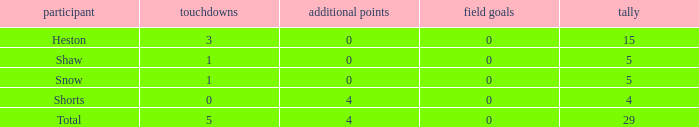Parse the table in full. {'header': ['participant', 'touchdowns', 'additional points', 'field goals', 'tally'], 'rows': [['Heston', '3', '0', '0', '15'], ['Shaw', '1', '0', '0', '5'], ['Snow', '1', '0', '0', '5'], ['Shorts', '0', '4', '0', '4'], ['Total', '5', '4', '0', '29']]} What is the total number of field goals a player had when there were more than 0 extra points and there were 5 touchdowns? 1.0. 